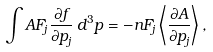<formula> <loc_0><loc_0><loc_500><loc_500>\int A F _ { j } { \frac { \partial f } { \partial p _ { j } } } \, d ^ { 3 } p = - n F _ { j } \left \langle { \frac { \partial A } { \partial p _ { j } } } \right \rangle ,</formula> 